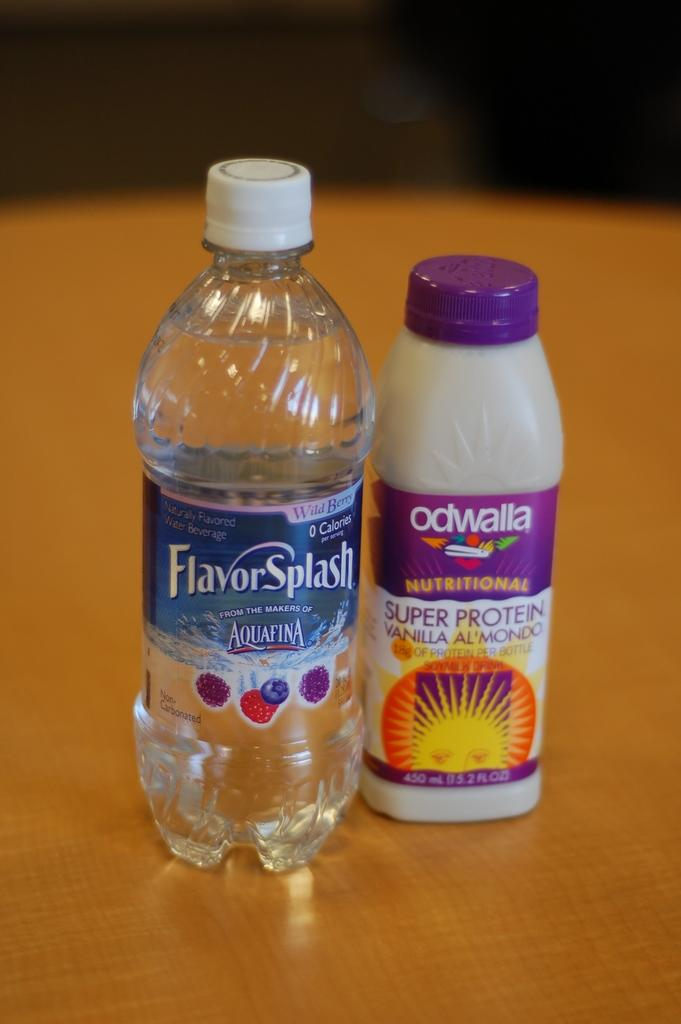<image>
Provide a brief description of the given image. Flavor Splash Aquaina Water Bottle with Odwalla drink next to it, that has super protein and vanilla almondo. 